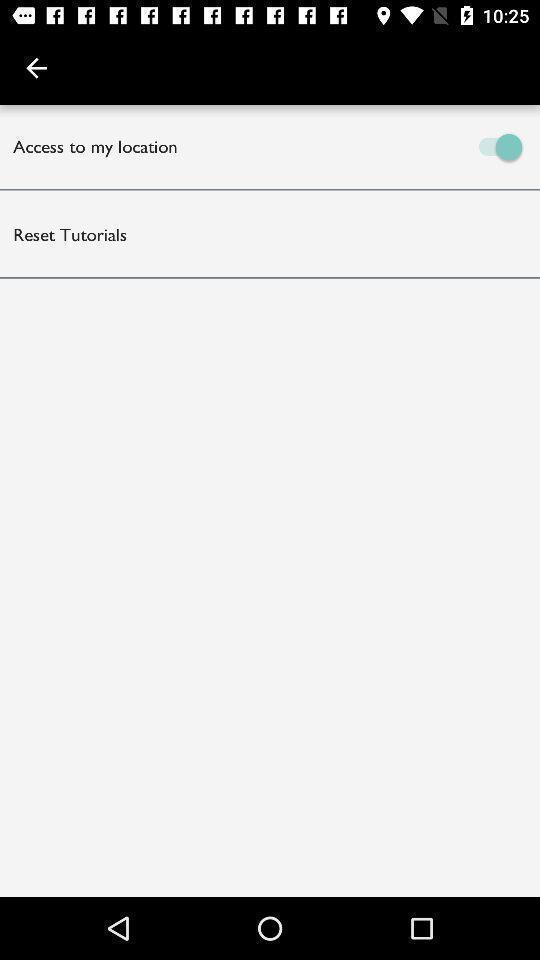Describe the content in this image. Two options on the screen for location and reset tutorials. 